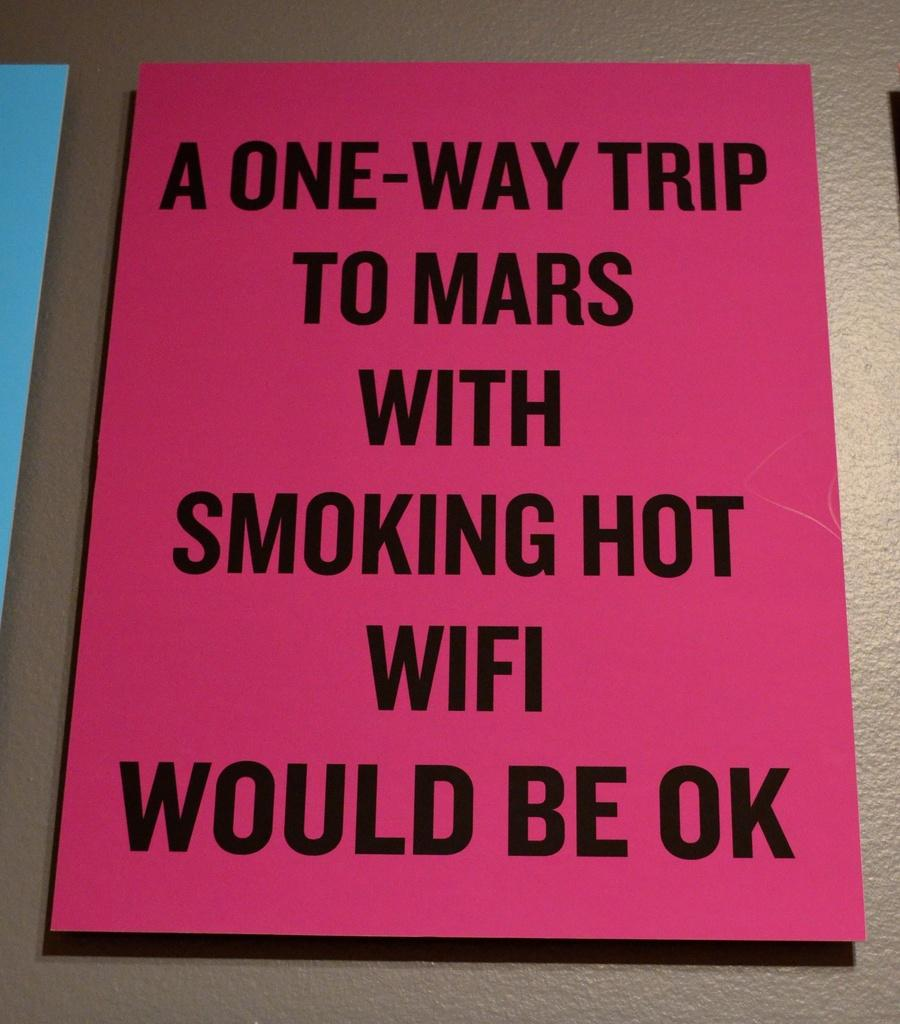<image>
Render a clear and concise summary of the photo. The sign suggests that a trip to Mars with fast wifi would be okay. 